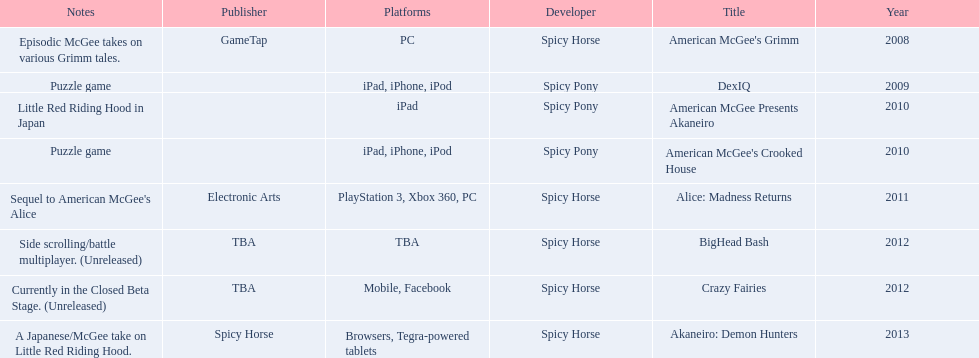What are all of the game titles? American McGee's Grimm, DexIQ, American McGee Presents Akaneiro, American McGee's Crooked House, Alice: Madness Returns, BigHead Bash, Crazy Fairies, Akaneiro: Demon Hunters. Which developer developed a game in 2011? Spicy Horse. Who published this game in 2011 Electronic Arts. What was the name of this published game in 2011? Alice: Madness Returns. 